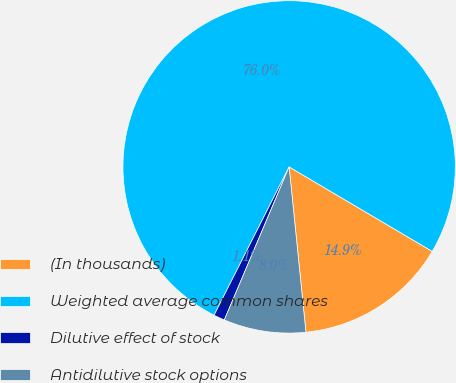Convert chart to OTSL. <chart><loc_0><loc_0><loc_500><loc_500><pie_chart><fcel>(In thousands)<fcel>Weighted average common shares<fcel>Dilutive effect of stock<fcel>Antidilutive stock options<nl><fcel>14.9%<fcel>76.03%<fcel>1.08%<fcel>7.99%<nl></chart> 